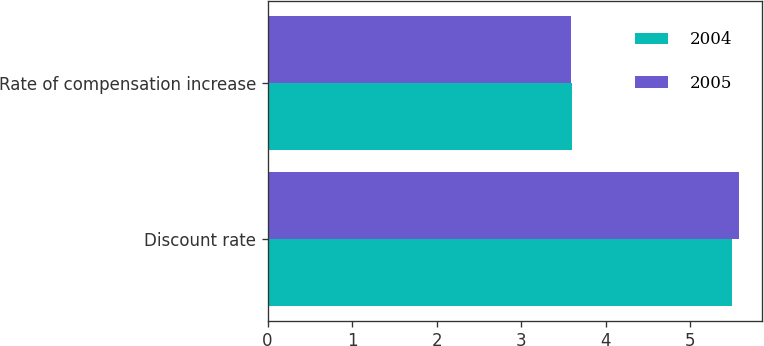Convert chart to OTSL. <chart><loc_0><loc_0><loc_500><loc_500><stacked_bar_chart><ecel><fcel>Discount rate<fcel>Rate of compensation increase<nl><fcel>2004<fcel>5.49<fcel>3.6<nl><fcel>2005<fcel>5.57<fcel>3.59<nl></chart> 